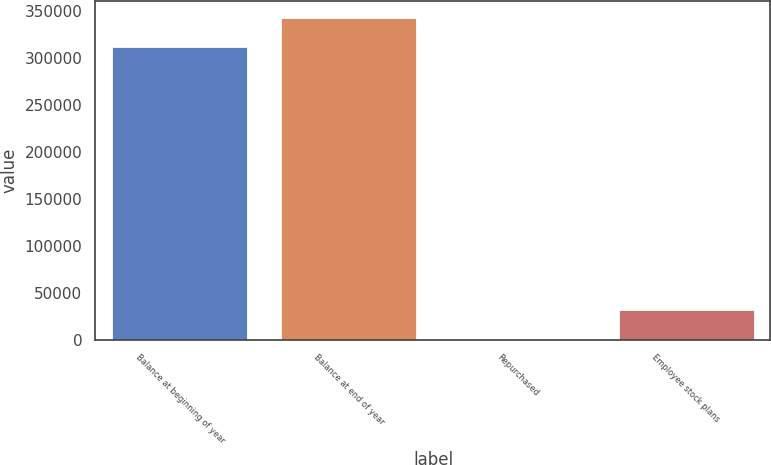Convert chart to OTSL. <chart><loc_0><loc_0><loc_500><loc_500><bar_chart><fcel>Balance at beginning of year<fcel>Balance at end of year<fcel>Repurchased<fcel>Employee stock plans<nl><fcel>312166<fcel>343380<fcel>27<fcel>31240.9<nl></chart> 